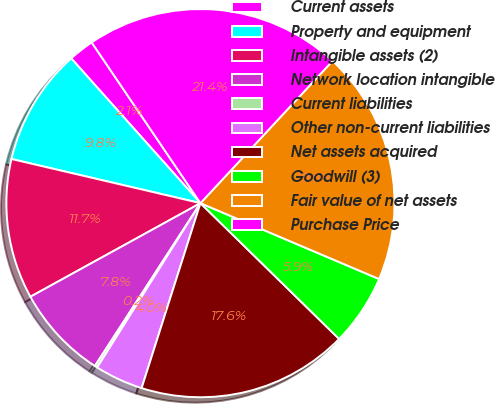<chart> <loc_0><loc_0><loc_500><loc_500><pie_chart><fcel>Current assets<fcel>Property and equipment<fcel>Intangible assets (2)<fcel>Network location intangible<fcel>Current liabilities<fcel>Other non-current liabilities<fcel>Net assets acquired<fcel>Goodwill (3)<fcel>Fair value of net assets<fcel>Purchase Price<nl><fcel>2.13%<fcel>9.75%<fcel>11.66%<fcel>7.84%<fcel>0.22%<fcel>4.03%<fcel>17.57%<fcel>5.94%<fcel>19.48%<fcel>21.38%<nl></chart> 